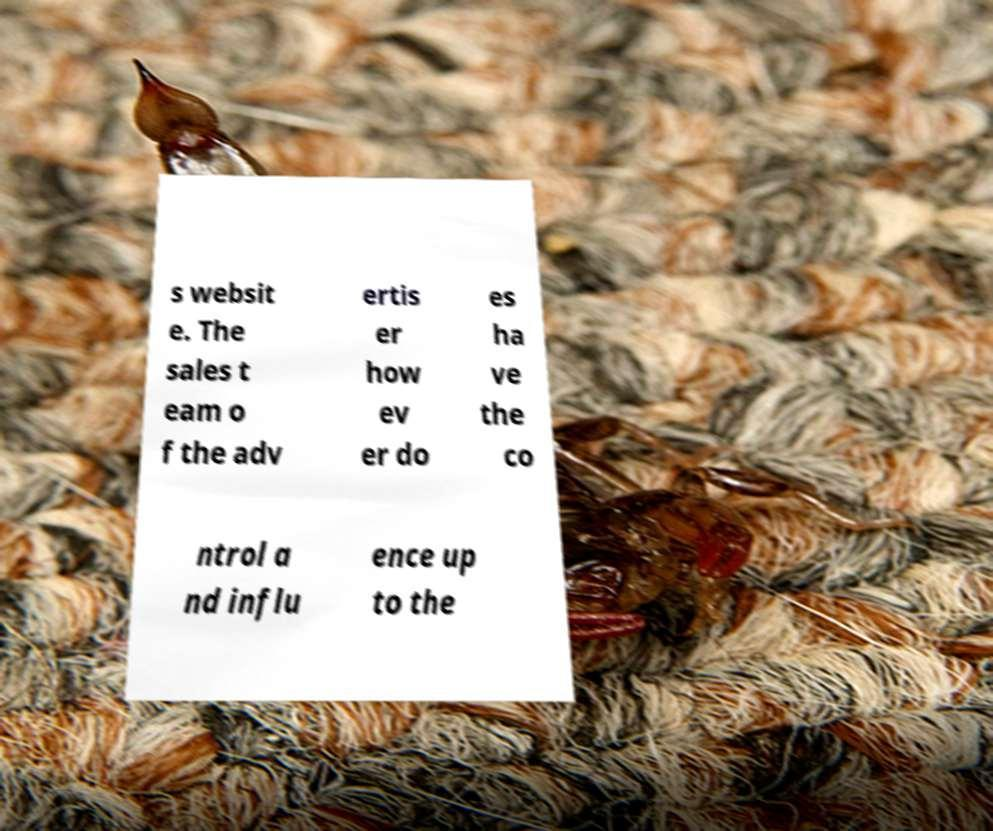Can you accurately transcribe the text from the provided image for me? s websit e. The sales t eam o f the adv ertis er how ev er do es ha ve the co ntrol a nd influ ence up to the 